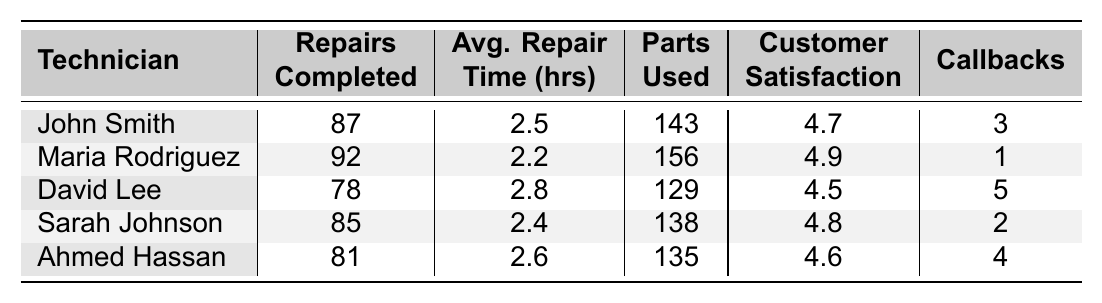What is the highest customer satisfaction rating among the technicians? The table lists the customer satisfaction ratings for each technician. The highest rating is for Maria Rodriguez at 4.9.
Answer: 4.9 Which technician completed the fewest repairs? Looking at the 'Repairs Completed' column, David Lee has the lowest count with 78 repairs completed.
Answer: David Lee What is the average repair time of Sarah Johnson? Sarah Johnson's average repair time is listed as 2.4 hours in the 'Avg. Repair Time' column.
Answer: 2.4 hours How many total repairs were completed by all technicians combined? Adding all values from the 'Repairs Completed' column: 87 + 92 + 78 + 85 + 81 = 423.
Answer: 423 Did any technician have more than 100 parts used? By checking the 'Parts Used' column, Maria Rodriguez used 156 parts, which is more than 100.
Answer: Yes Which technician had the most callbacks? Referring to the 'Callbacks' column, David Lee had the most callbacks with a total of 5.
Answer: David Lee What is the difference in average repair time between John Smith and Maria Rodriguez? John's average repair time is 2.5 hours, and Maria's is 2.2 hours. The difference is 2.5 - 2.2 = 0.3 hours.
Answer: 0.3 hours Calculate the average customer satisfaction rating across all technicians. Adding the ratings: (4.7 + 4.9 + 4.5 + 4.8 + 4.6) = 24.5. Then divide by 5 technicians: 24.5 / 5 = 4.9.
Answer: 4.9 Who completed more repairs, Sarah Johnson or Ahmed Hassan? Sarah Johnson completed 85 repairs, while Ahmed Hassan completed 81, so Sarah has more repairs completed.
Answer: Sarah Johnson Is it true that Maria Rodriguez has the highest number of repairs completed? Checking the 'Repairs Completed' column, Maria Rodriguez completed 92 repairs, which is more than any other technician.
Answer: Yes 